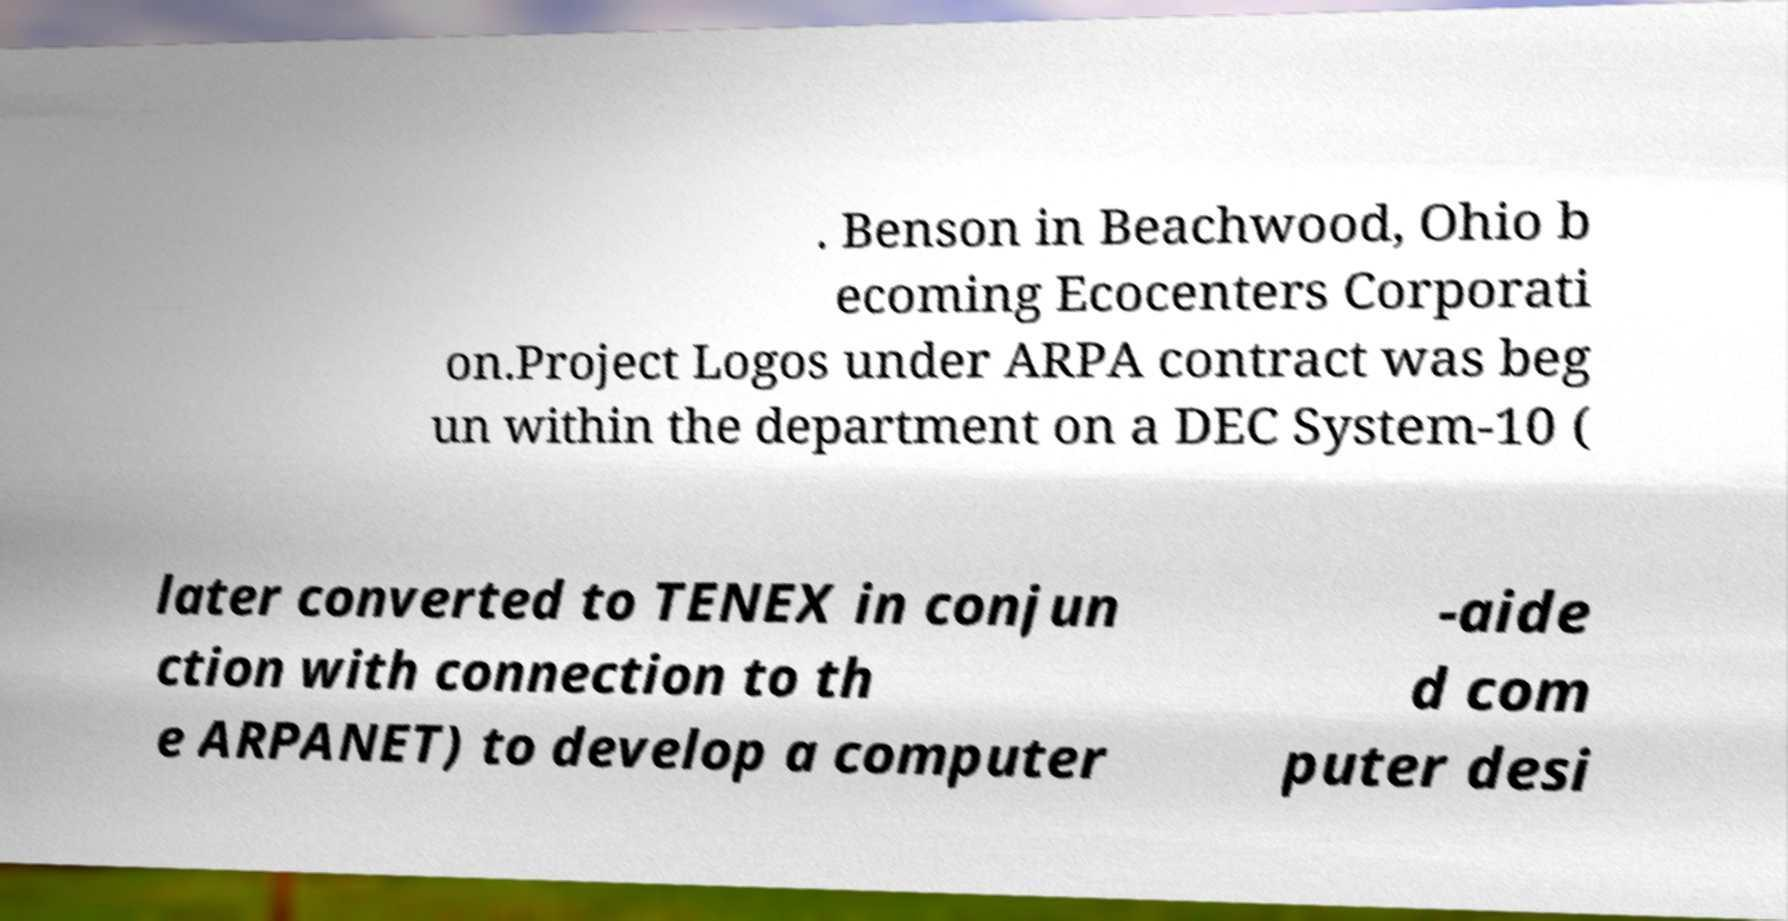Can you read and provide the text displayed in the image?This photo seems to have some interesting text. Can you extract and type it out for me? . Benson in Beachwood, Ohio b ecoming Ecocenters Corporati on.Project Logos under ARPA contract was beg un within the department on a DEC System-10 ( later converted to TENEX in conjun ction with connection to th e ARPANET) to develop a computer -aide d com puter desi 